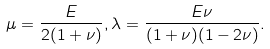Convert formula to latex. <formula><loc_0><loc_0><loc_500><loc_500>\mu = \frac { E } { 2 ( 1 + \nu ) } , \lambda = \frac { E \nu } { ( 1 + \nu ) ( 1 - 2 \nu ) } .</formula> 